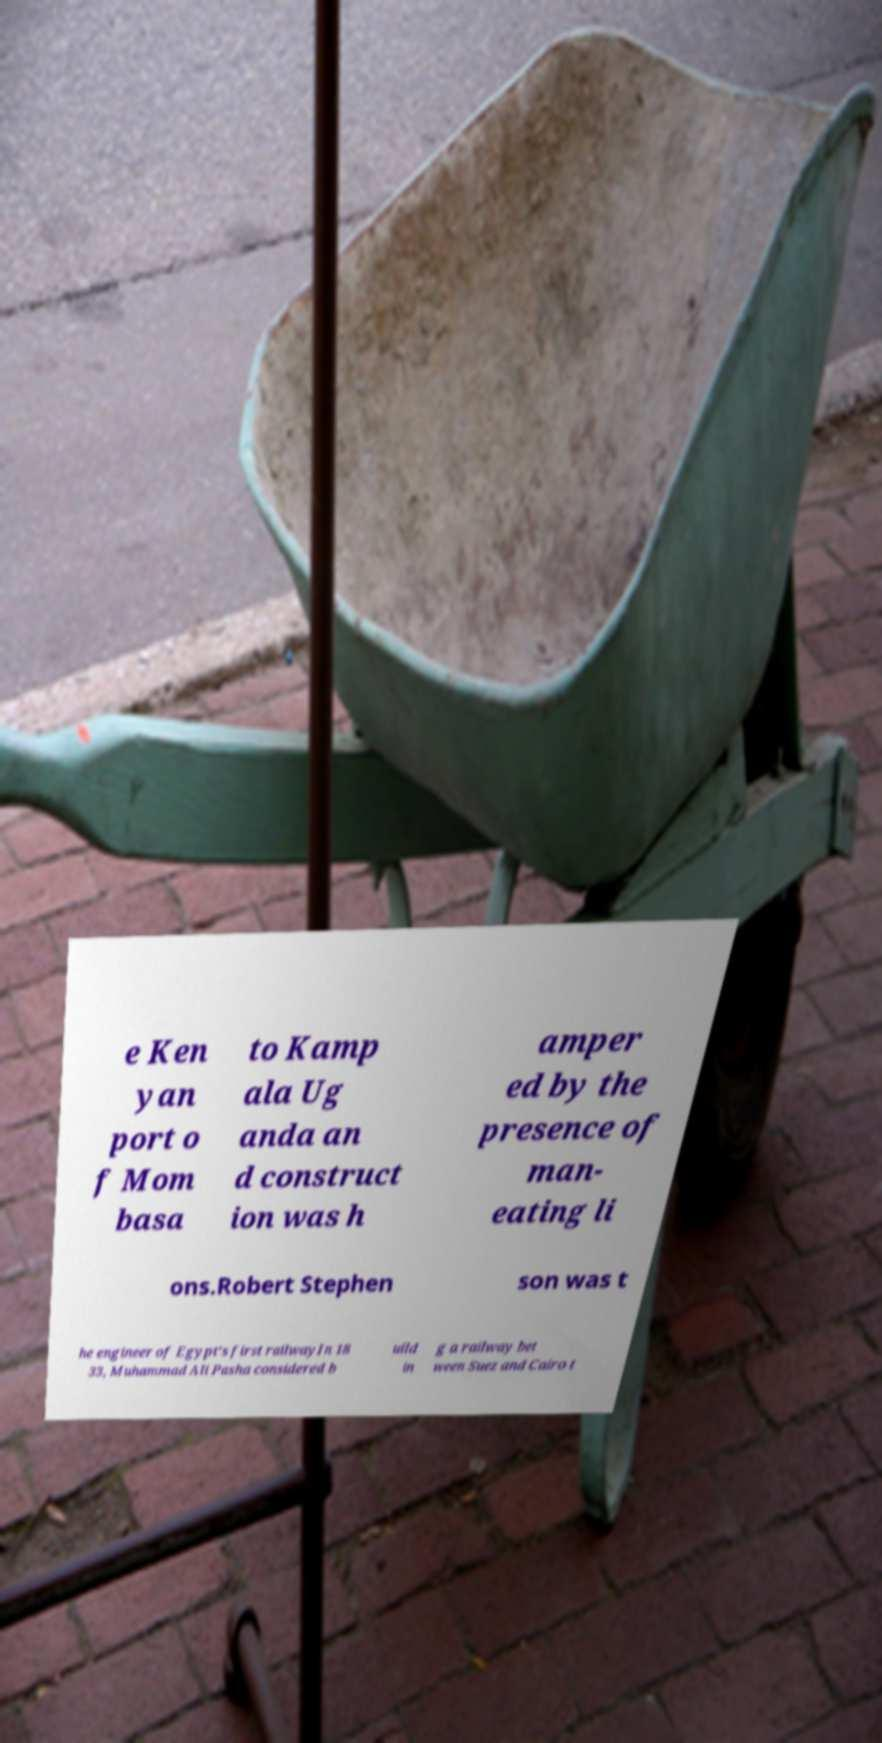Could you assist in decoding the text presented in this image and type it out clearly? e Ken yan port o f Mom basa to Kamp ala Ug anda an d construct ion was h amper ed by the presence of man- eating li ons.Robert Stephen son was t he engineer of Egypt's first railwayIn 18 33, Muhammad Ali Pasha considered b uild in g a railway bet ween Suez and Cairo t 